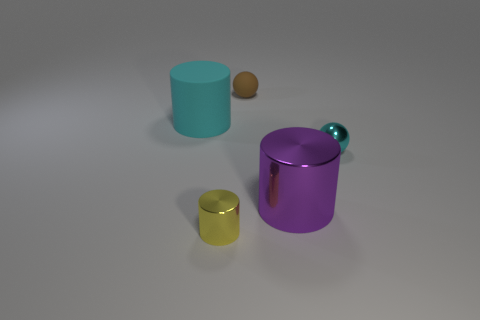Add 3 big purple metal things. How many objects exist? 8 Subtract all cylinders. How many objects are left? 2 Add 2 cyan cylinders. How many cyan cylinders exist? 3 Subtract 0 brown cylinders. How many objects are left? 5 Subtract all gray cylinders. Subtract all cyan things. How many objects are left? 3 Add 4 shiny balls. How many shiny balls are left? 5 